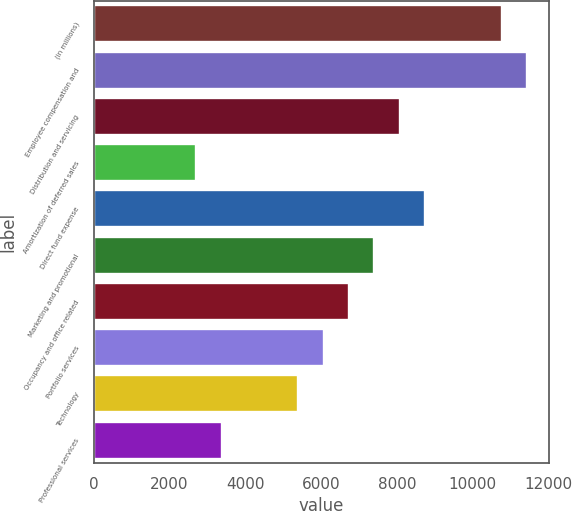<chart> <loc_0><loc_0><loc_500><loc_500><bar_chart><fcel>(in millions)<fcel>Employee compensation and<fcel>Distribution and servicing<fcel>Amortization of deferred sales<fcel>Direct fund expense<fcel>Marketing and promotional<fcel>Occupancy and office related<fcel>Portfolio services<fcel>Technology<fcel>Professional services<nl><fcel>10764.8<fcel>11436.1<fcel>8079.6<fcel>2709.2<fcel>8750.9<fcel>7408.3<fcel>6737<fcel>6065.7<fcel>5394.4<fcel>3380.5<nl></chart> 